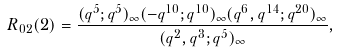<formula> <loc_0><loc_0><loc_500><loc_500>R _ { 0 2 } ( 2 ) = \frac { ( q ^ { 5 } ; q ^ { 5 } ) _ { \infty } ( - q ^ { 1 0 } ; q ^ { 1 0 } ) _ { \infty } ( q ^ { 6 } , q ^ { 1 4 } ; q ^ { 2 0 } ) _ { \infty } } { ( q ^ { 2 } , q ^ { 3 } ; q ^ { 5 } ) _ { \infty } } ,</formula> 